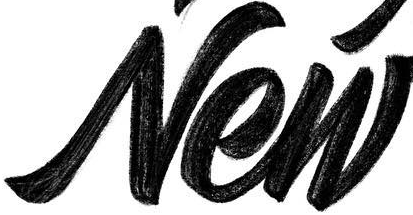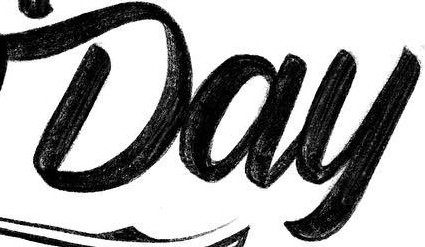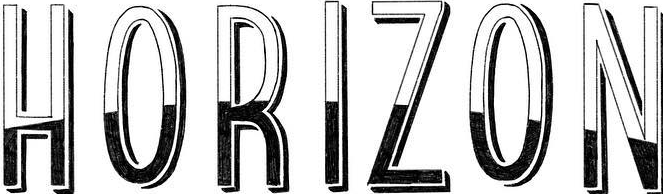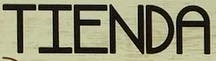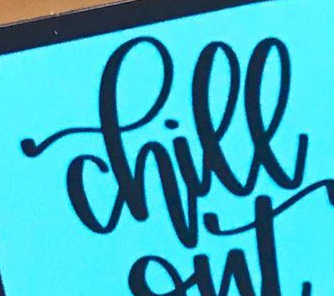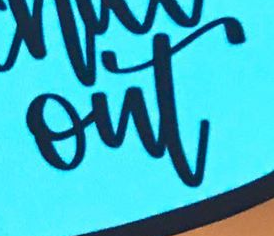Transcribe the words shown in these images in order, separated by a semicolon. New; Day; HORIZON; TIENDA; chill; out 